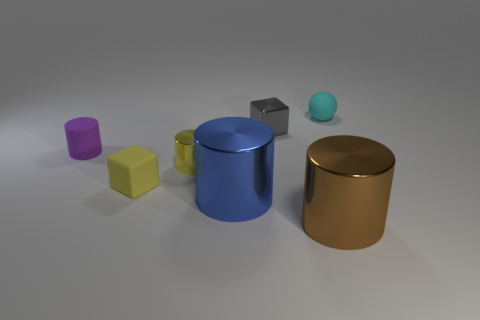How many purple things are small objects or rubber cubes?
Provide a succinct answer. 1. How many blue metallic things are on the right side of the tiny cyan ball?
Offer a very short reply. 0. Are there more small gray metal objects than green rubber spheres?
Your answer should be compact. Yes. What is the shape of the big thing on the right side of the small block behind the purple matte cylinder?
Your answer should be compact. Cylinder. Is the matte block the same color as the tiny metal cylinder?
Your answer should be very brief. Yes. Is the number of tiny things right of the yellow cube greater than the number of cubes?
Keep it short and to the point. Yes. There is a small metal thing to the right of the blue metal cylinder; what number of objects are in front of it?
Provide a short and direct response. 5. Do the big cylinder that is right of the metal cube and the cube that is in front of the tiny purple object have the same material?
Provide a short and direct response. No. What material is the cube that is the same color as the small metallic cylinder?
Your answer should be very brief. Rubber. How many large blue shiny things are the same shape as the small yellow metal object?
Your answer should be very brief. 1. 